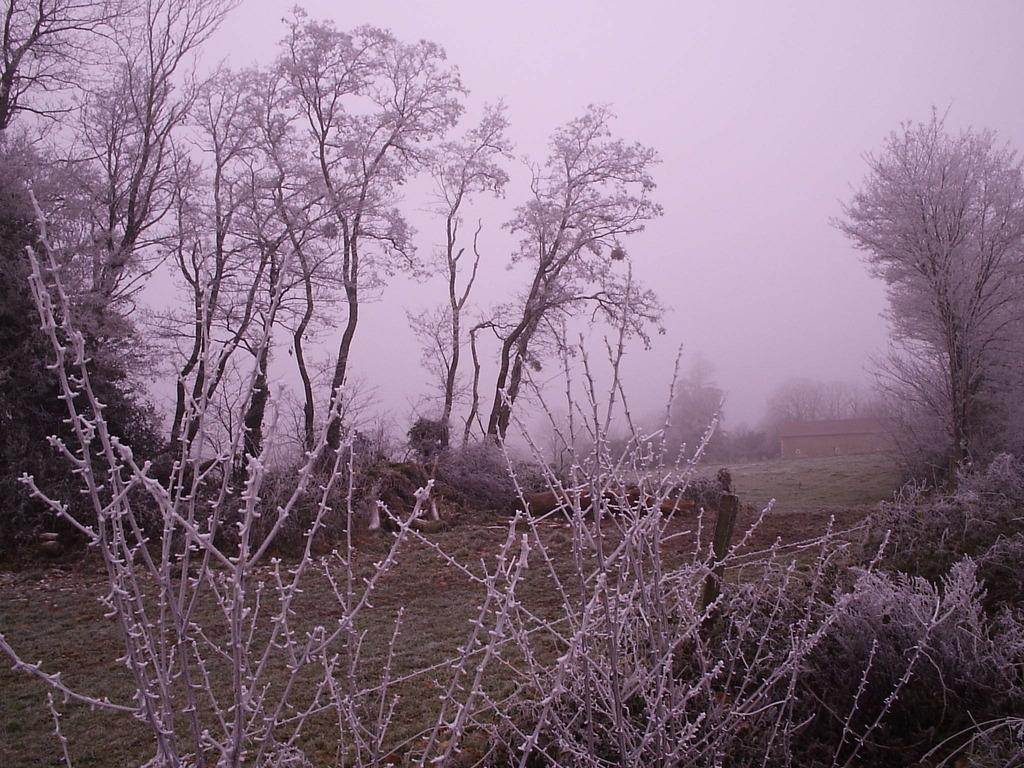What type of vegetation is present in the image? There is a tree and grass in the image. What type of structures can be seen in the image? There are houses in the image. What is the weather like in the image? There is snow visible in the image, indicating a cold or wintery environment. What type of marble is used in the construction of the houses in the image? There is no mention of marble in the construction of the houses in the image. What tax rate applies to the houses in the image? There is no information about tax rates in the image. 